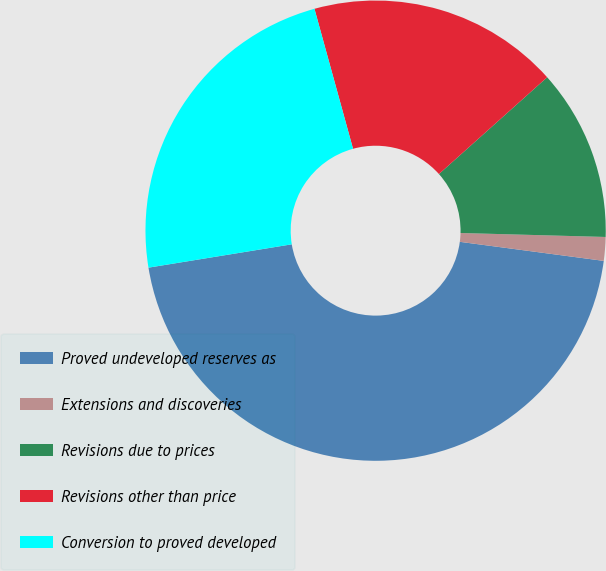<chart> <loc_0><loc_0><loc_500><loc_500><pie_chart><fcel>Proved undeveloped reserves as<fcel>Extensions and discoveries<fcel>Revisions due to prices<fcel>Revisions other than price<fcel>Conversion to proved developed<nl><fcel>45.34%<fcel>1.66%<fcel>12.05%<fcel>17.67%<fcel>23.29%<nl></chart> 